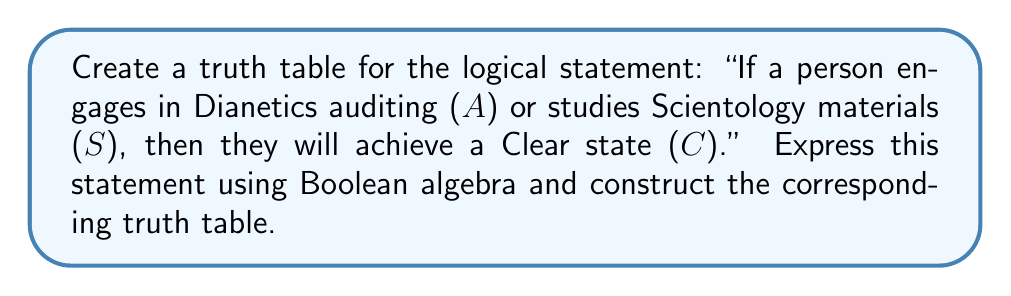Can you solve this math problem? Let's approach this step-by-step:

1) First, we need to express the statement in Boolean algebra. The logical statement can be written as:

   $$(A \lor S) \rightarrow C$$

   Where $\lor$ represents "or" and $\rightarrow$ represents "if...then".

2) We can rewrite this using only AND, OR, and NOT operations:

   $$\lnot(A \lor S) \lor C$$

3) Now, let's construct the truth table. We have three variables (A, S, C), so we'll have $2^3 = 8$ rows in our truth table.

4) First, list all possible combinations of A, S, and C:

   | A | S | C |
   |---|---|---|
   | 0 | 0 | 0 |
   | 0 | 0 | 1 |
   | 0 | 1 | 0 |
   | 0 | 1 | 1 |
   | 1 | 0 | 0 |
   | 1 | 0 | 1 |
   | 1 | 1 | 0 |
   | 1 | 1 | 1 |

5) Now, let's evaluate $(A \lor S)$:

   | A | S | C | $(A \lor S)$ |
   |---|---|---|--------------|
   | 0 | 0 | 0 |      0       |
   | 0 | 0 | 1 |      0       |
   | 0 | 1 | 0 |      1       |
   | 0 | 1 | 1 |      1       |
   | 1 | 0 | 0 |      1       |
   | 1 | 0 | 1 |      1       |
   | 1 | 1 | 0 |      1       |
   | 1 | 1 | 1 |      1       |

6) Next, we negate $(A \lor S)$ to get $\lnot(A \lor S)$:

   | A | S | C | $(A \lor S)$ | $\lnot(A \lor S)$ |
   |---|---|---|--------------|-------------------|
   | 0 | 0 | 0 |      0       |         1         |
   | 0 | 0 | 1 |      0       |         1         |
   | 0 | 1 | 0 |      1       |         0         |
   | 0 | 1 | 1 |      1       |         0         |
   | 1 | 0 | 0 |      1       |         0         |
   | 1 | 0 | 1 |      1       |         0         |
   | 1 | 1 | 0 |      1       |         0         |
   | 1 | 1 | 1 |      1       |         0         |

7) Finally, we OR this result with C to get our final expression $\lnot(A \lor S) \lor C$:

   | A | S | C | $(A \lor S)$ | $\lnot(A \lor S)$ | $\lnot(A \lor S) \lor C$ |
   |---|---|---|--------------|-------------------|--------------------------|
   | 0 | 0 | 0 |      0       |         1         |            1             |
   | 0 | 0 | 1 |      0       |         1         |            1             |
   | 0 | 1 | 0 |      1       |         0         |            0             |
   | 0 | 1 | 1 |      1       |         0         |            1             |
   | 1 | 0 | 0 |      1       |         0         |            0             |
   | 1 | 0 | 1 |      1       |         0         |            1             |
   | 1 | 1 | 0 |      1       |         0         |            0             |
   | 1 | 1 | 1 |      1       |         0         |            1             |

This completes our truth table for the given logical statement.
Answer: | A | S | C | $\lnot(A \lor S) \lor C$ |
|---|---|---|--------------------------|
| 0 | 0 | 0 |            1             |
| 0 | 0 | 1 |            1             |
| 0 | 1 | 0 |            0             |
| 0 | 1 | 1 |            1             |
| 1 | 0 | 0 |            0             |
| 1 | 0 | 1 |            1             |
| 1 | 1 | 0 |            0             |
| 1 | 1 | 1 |            1             | 